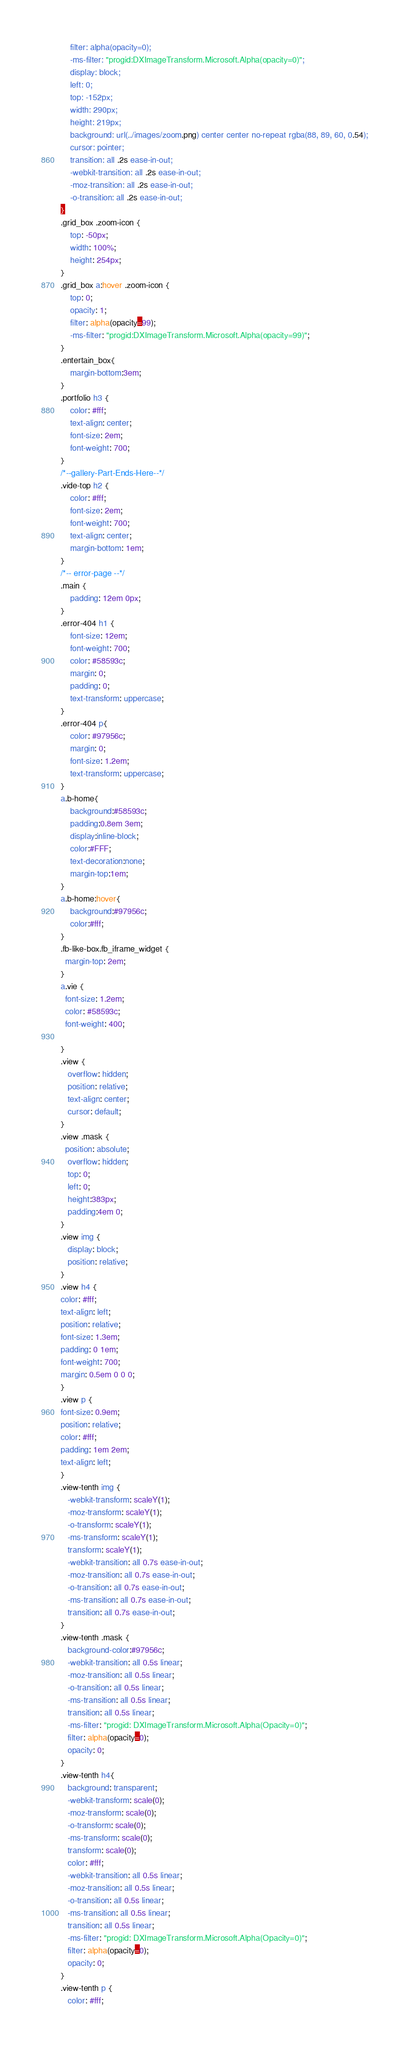<code> <loc_0><loc_0><loc_500><loc_500><_CSS_>	filter: alpha(opacity=0);
	-ms-filter: "progid:DXImageTransform.Microsoft.Alpha(opacity=0)";
	display: block;
	left: 0;
	top: -152px;
	width: 290px;
	height: 219px;
	background: url(../images/zoom.png) center center no-repeat rgba(88, 89, 60, 0.54);
	cursor: pointer;
	transition: all .2s ease-in-out;
	-webkit-transition: all .2s ease-in-out;
	-moz-transition: all .2s ease-in-out;
	-o-transition: all .2s ease-in-out;
}
.grid_box .zoom-icon {
	top: -50px;
	width: 100%;
	height: 254px;
}
.grid_box a:hover .zoom-icon {
	top: 0;
	opacity: 1;
	filter: alpha(opacity=99); 
	-ms-filter: "progid:DXImageTransform.Microsoft.Alpha(opacity=99)";
}
.entertain_box{
	margin-bottom:3em;
}
.portfolio h3 {
	color: #fff;
	text-align: center;
	font-size: 2em;
	font-weight: 700;
}
/*--gallery-Part-Ends-Here--*/
.vide-top h2 {
	color: #fff;
	font-size: 2em;
	font-weight: 700;
	text-align: center;
	margin-bottom: 1em;
}
/*-- error-page --*/
.main {
	padding: 12em 0px;
}
.error-404 h1 {
	font-size: 12em;
	font-weight: 700;
	color: #58593c;
	margin: 0;
	padding: 0;
	text-transform: uppercase;
}
.error-404 p{
	color: #97956c;
	margin: 0;
	font-size: 1.2em;
	text-transform: uppercase;
} 
a.b-home{
	background:#58593c;
	padding:0.8em 3em;
	display:inline-block;
	color:#FFF;
	text-decoration:none;
	margin-top:1em;
}
a.b-home:hover{
	background:#97956c;
	color:#fff;
}
.fb-like-box.fb_iframe_widget {
  margin-top: 2em;
}
a.vie {
  font-size: 1.2em;
  color: #58593c;
  font-weight: 400;

}
.view {
   overflow: hidden;
   position: relative;
   text-align: center;
   cursor: default;
}
.view .mask {
  position: absolute;
   overflow: hidden;
   top: 0;
   left: 0;
   height:383px;
   padding:4em 0;
}
.view img {
   display: block;
   position: relative;
}
.view h4 {
color: #fff;
text-align: left;
position: relative;
font-size: 1.3em;
padding: 0 1em;
font-weight: 700;
margin: 0.5em 0 0 0;
}
.view p {
font-size: 0.9em;
position: relative;
color: #fff;
padding: 1em 2em;
text-align: left;
}
.view-tenth img {
   -webkit-transform: scaleY(1);
   -moz-transform: scaleY(1);
   -o-transform: scaleY(1);
   -ms-transform: scaleY(1);
   transform: scaleY(1);
   -webkit-transition: all 0.7s ease-in-out;
   -moz-transition: all 0.7s ease-in-out;
   -o-transition: all 0.7s ease-in-out;
   -ms-transition: all 0.7s ease-in-out;
   transition: all 0.7s ease-in-out;
}
.view-tenth .mask {
   background-color:#97956c;
   -webkit-transition: all 0.5s linear;
   -moz-transition: all 0.5s linear;
   -o-transition: all 0.5s linear;
   -ms-transition: all 0.5s linear;
   transition: all 0.5s linear;
   -ms-filter: "progid: DXImageTransform.Microsoft.Alpha(Opacity=0)";
   filter: alpha(opacity=0);
   opacity: 0;
}
.view-tenth h4{
   background: transparent;
   -webkit-transform: scale(0);
   -moz-transform: scale(0);
   -o-transform: scale(0);
   -ms-transform: scale(0);
   transform: scale(0);
   color: #fff;
   -webkit-transition: all 0.5s linear;
   -moz-transition: all 0.5s linear;
   -o-transition: all 0.5s linear;
   -ms-transition: all 0.5s linear;
   transition: all 0.5s linear;
   -ms-filter: "progid: DXImageTransform.Microsoft.Alpha(Opacity=0)";
   filter: alpha(opacity=0);
   opacity: 0;
}
.view-tenth p {
   color: #fff;</code> 